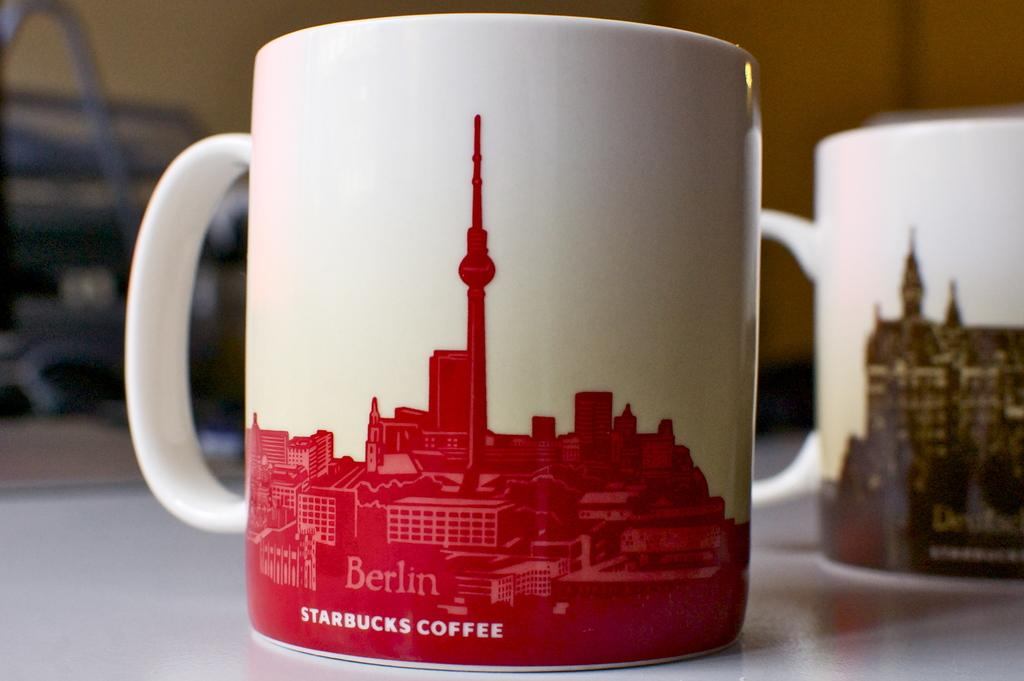<image>
Present a compact description of the photo's key features. A coffee cup from Starbucks showing the city Berlin 